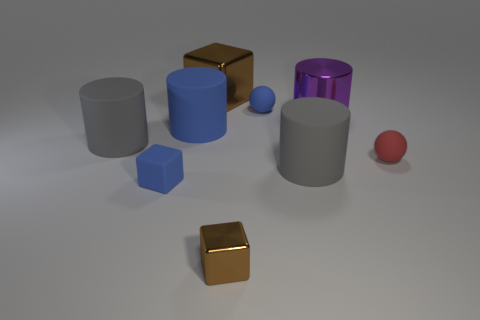There is a large thing that is in front of the large blue rubber object and behind the tiny red matte thing; what shape is it? The object in question is a cylinder with a matte finish. Positioned between the forefront, where the large blue rubber cylinder stands, and the background featuring a small red sphere, this cylindrical object exhibits a combination of geometric simplicity and a subtle texture that distinguishes it in the setting. 